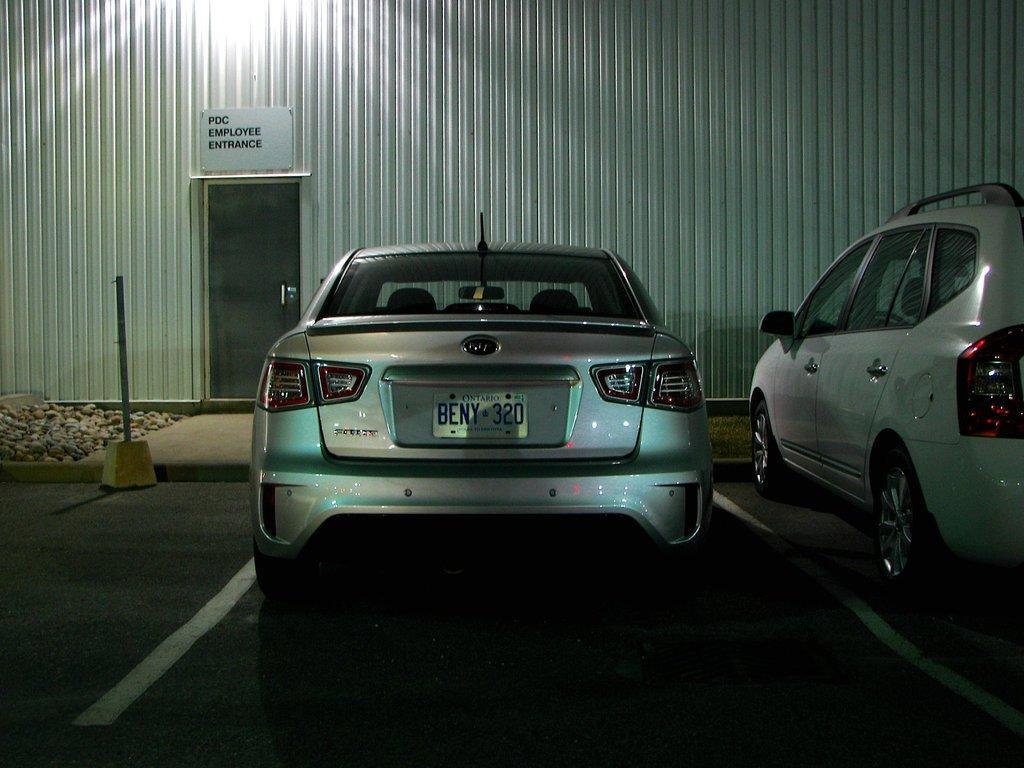Can you describe this image briefly? In this image we can see a few vehicles on the road, there are some stones, we can see a pole and a door, there is a wall, on the wall we can see a poster with some text. 